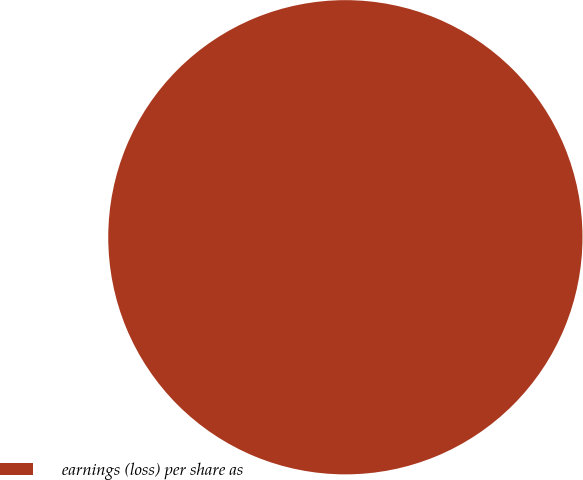<chart> <loc_0><loc_0><loc_500><loc_500><pie_chart><fcel>earnings (loss) per share as<nl><fcel>100.0%<nl></chart> 